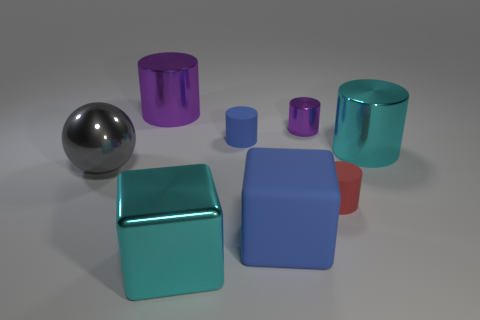What size is the metal object that is left of the big blue cube and behind the cyan cylinder?
Your answer should be compact. Large. The big blue rubber object is what shape?
Offer a very short reply. Cube. What number of big blue things are the same shape as the large purple metallic object?
Your answer should be very brief. 0. Are there fewer blue rubber cubes that are to the left of the large metal ball than cyan metallic things in front of the big cyan metal cylinder?
Keep it short and to the point. Yes. There is a tiny cylinder on the left side of the big blue block; how many metal things are on the left side of it?
Keep it short and to the point. 3. Are there any small gray rubber blocks?
Provide a succinct answer. No. Is there a big green cylinder made of the same material as the big cyan cylinder?
Ensure brevity in your answer.  No. Are there more tiny purple metal objects on the right side of the blue rubber cylinder than cyan things that are in front of the big gray metallic thing?
Give a very brief answer. No. Is the size of the red thing the same as the metal cube?
Ensure brevity in your answer.  No. There is a big shiny thing that is on the right side of the rubber cylinder behind the red rubber cylinder; what color is it?
Provide a short and direct response. Cyan. 